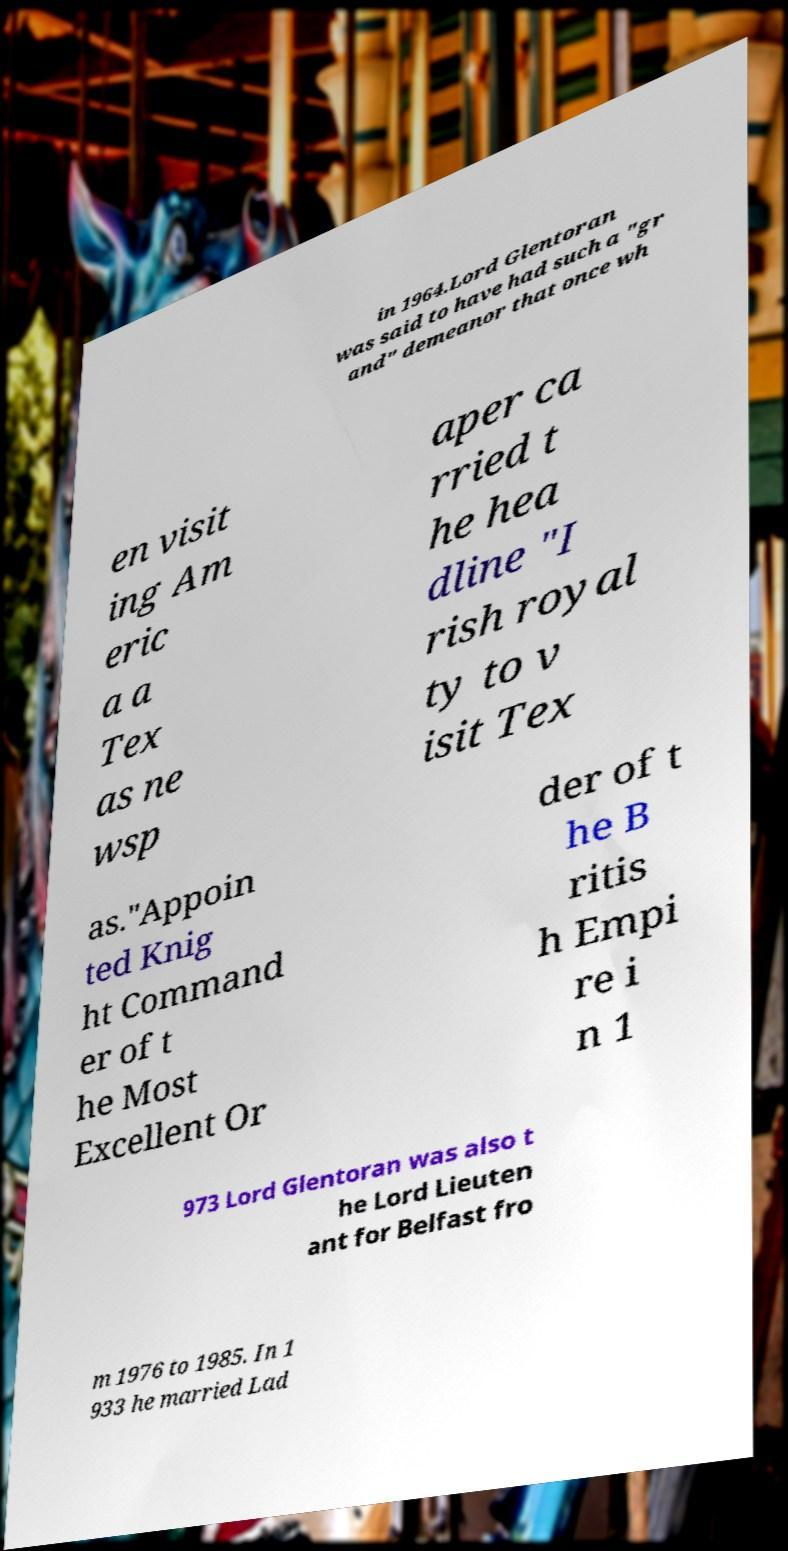What messages or text are displayed in this image? I need them in a readable, typed format. in 1964.Lord Glentoran was said to have had such a "gr and" demeanor that once wh en visit ing Am eric a a Tex as ne wsp aper ca rried t he hea dline "I rish royal ty to v isit Tex as."Appoin ted Knig ht Command er of t he Most Excellent Or der of t he B ritis h Empi re i n 1 973 Lord Glentoran was also t he Lord Lieuten ant for Belfast fro m 1976 to 1985. In 1 933 he married Lad 